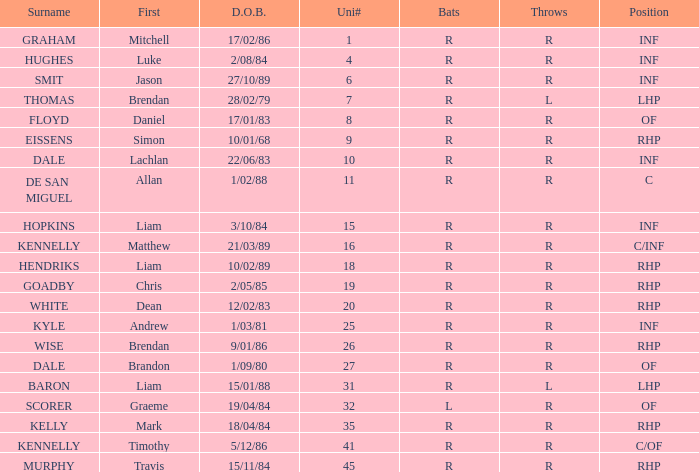Could you parse the entire table? {'header': ['Surname', 'First', 'D.O.B.', 'Uni#', 'Bats', 'Throws', 'Position'], 'rows': [['GRAHAM', 'Mitchell', '17/02/86', '1', 'R', 'R', 'INF'], ['HUGHES', 'Luke', '2/08/84', '4', 'R', 'R', 'INF'], ['SMIT', 'Jason', '27/10/89', '6', 'R', 'R', 'INF'], ['THOMAS', 'Brendan', '28/02/79', '7', 'R', 'L', 'LHP'], ['FLOYD', 'Daniel', '17/01/83', '8', 'R', 'R', 'OF'], ['EISSENS', 'Simon', '10/01/68', '9', 'R', 'R', 'RHP'], ['DALE', 'Lachlan', '22/06/83', '10', 'R', 'R', 'INF'], ['DE SAN MIGUEL', 'Allan', '1/02/88', '11', 'R', 'R', 'C'], ['HOPKINS', 'Liam', '3/10/84', '15', 'R', 'R', 'INF'], ['KENNELLY', 'Matthew', '21/03/89', '16', 'R', 'R', 'C/INF'], ['HENDRIKS', 'Liam', '10/02/89', '18', 'R', 'R', 'RHP'], ['GOADBY', 'Chris', '2/05/85', '19', 'R', 'R', 'RHP'], ['WHITE', 'Dean', '12/02/83', '20', 'R', 'R', 'RHP'], ['KYLE', 'Andrew', '1/03/81', '25', 'R', 'R', 'INF'], ['WISE', 'Brendan', '9/01/86', '26', 'R', 'R', 'RHP'], ['DALE', 'Brandon', '1/09/80', '27', 'R', 'R', 'OF'], ['BARON', 'Liam', '15/01/88', '31', 'R', 'L', 'LHP'], ['SCORER', 'Graeme', '19/04/84', '32', 'L', 'R', 'OF'], ['KELLY', 'Mark', '18/04/84', '35', 'R', 'R', 'RHP'], ['KENNELLY', 'Timothy', '5/12/86', '41', 'R', 'R', 'C/OF'], ['MURPHY', 'Travis', '15/11/84', '45', 'R', 'R', 'RHP']]} Which batter has the last name Graham? R. 